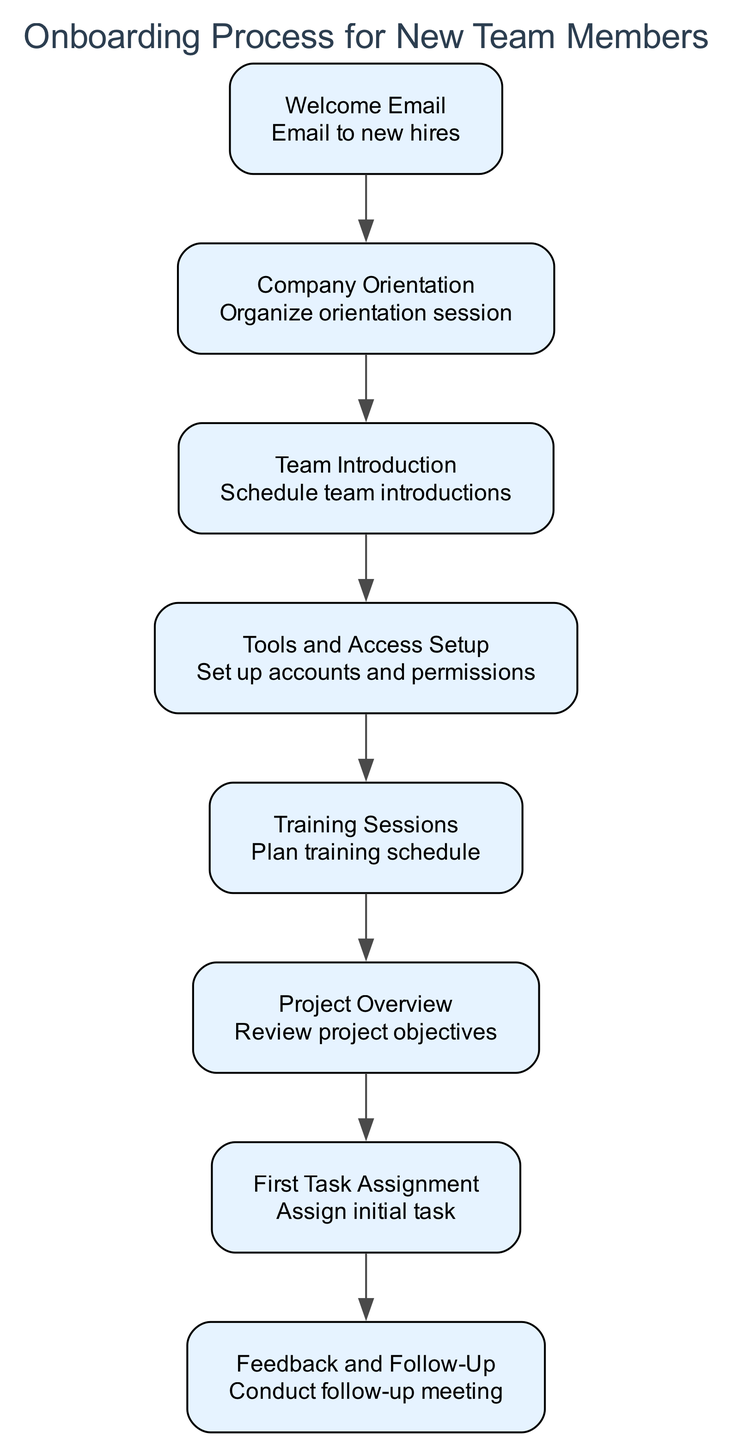What is the first step in the onboarding process? The first step listed in the diagram is the "Welcome Email." It initiates the onboarding process by introducing the company culture and objectives.
Answer: Welcome Email How many steps are in the onboarding process? By counting all the distinct steps listed in the diagram, there are a total of eight steps in the onboarding process.
Answer: 8 What action is associated with the "Training Sessions" step? The action associated with the "Training Sessions" step is "Plan training schedule," indicating what should be done during that specific step.
Answer: Plan training schedule Which step follows "Team Introduction"? The "Tools and Access Setup" step follows directly after the "Team Introduction" step, indicating the next action in the sequence of the onboarding process.
Answer: Tools and Access Setup What is the last step of the onboarding process? The final step in the onboarding process is "Feedback and Follow-Up," which is crucial for assessing the new member's integration and addressing any challenges.
Answer: Feedback and Follow-Up What does the "Project Overview" step describe? The "Project Overview" step gives an overview of ongoing projects and clarifies the new member's specific role within those projects, which helps them understand their contributions.
Answer: Overview of ongoing projects and role Which two steps are connected directly by an edge? The "Training Sessions" step is directly connected to the "Project Overview" step by an edge, indicating a sequential flow in the onboarding tasks.
Answer: Training Sessions and Project Overview What is the main objective of the "Company Orientation" step? The objective of the "Company Orientation" step is to explain company policies, tools, and structure, which is essential for new members to understand their environment.
Answer: Explain company policies, tools, and structure 